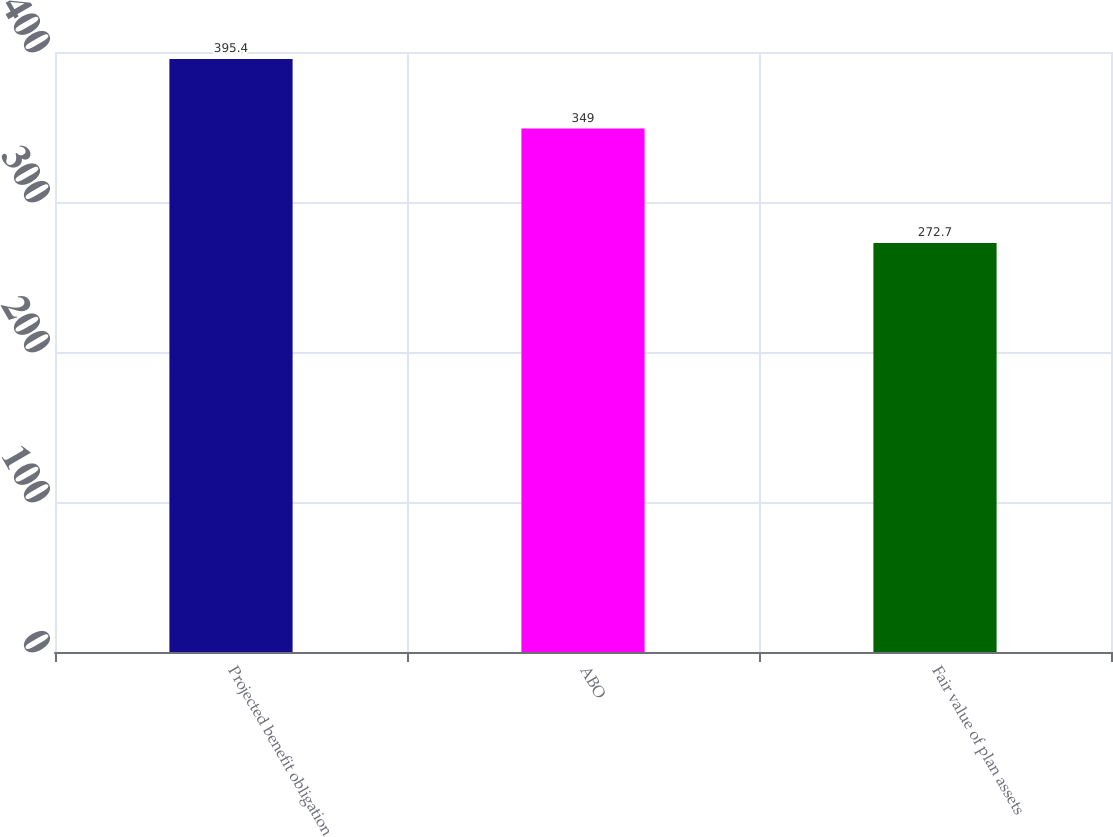Convert chart. <chart><loc_0><loc_0><loc_500><loc_500><bar_chart><fcel>Projected benefit obligation<fcel>ABO<fcel>Fair value of plan assets<nl><fcel>395.4<fcel>349<fcel>272.7<nl></chart> 